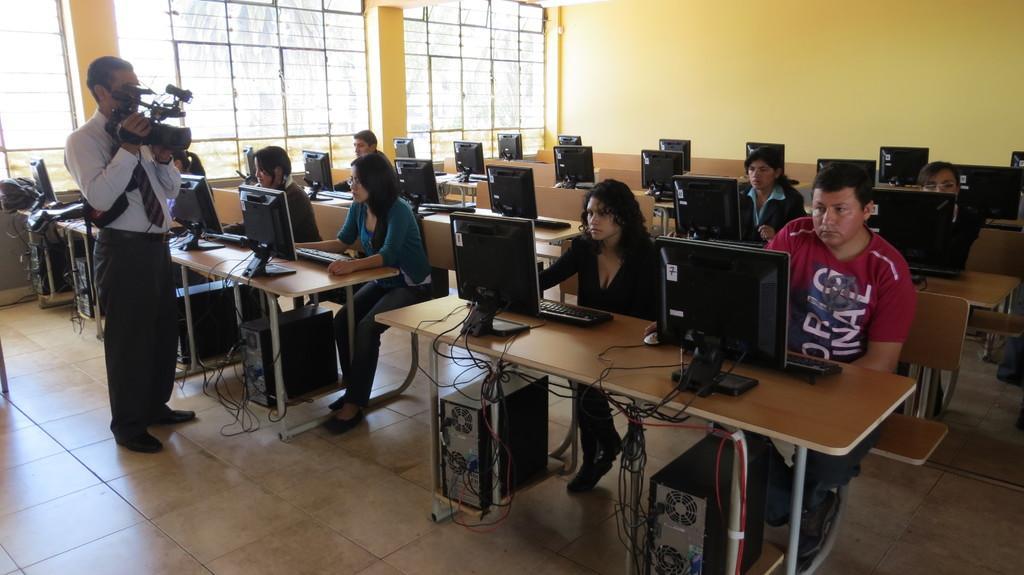Can you describe this image briefly? There is a class and its a computer lab where students are working, there are monitors connected to the CPU. There are eight students in the class and the floor is of tiles, there is a man who is in formal attire taking the video of the class and opposite to the man there is a wall which is of yellow colour beside the wall there is a window, beside the window there is a pillar and next to the pillar there is a window again. 